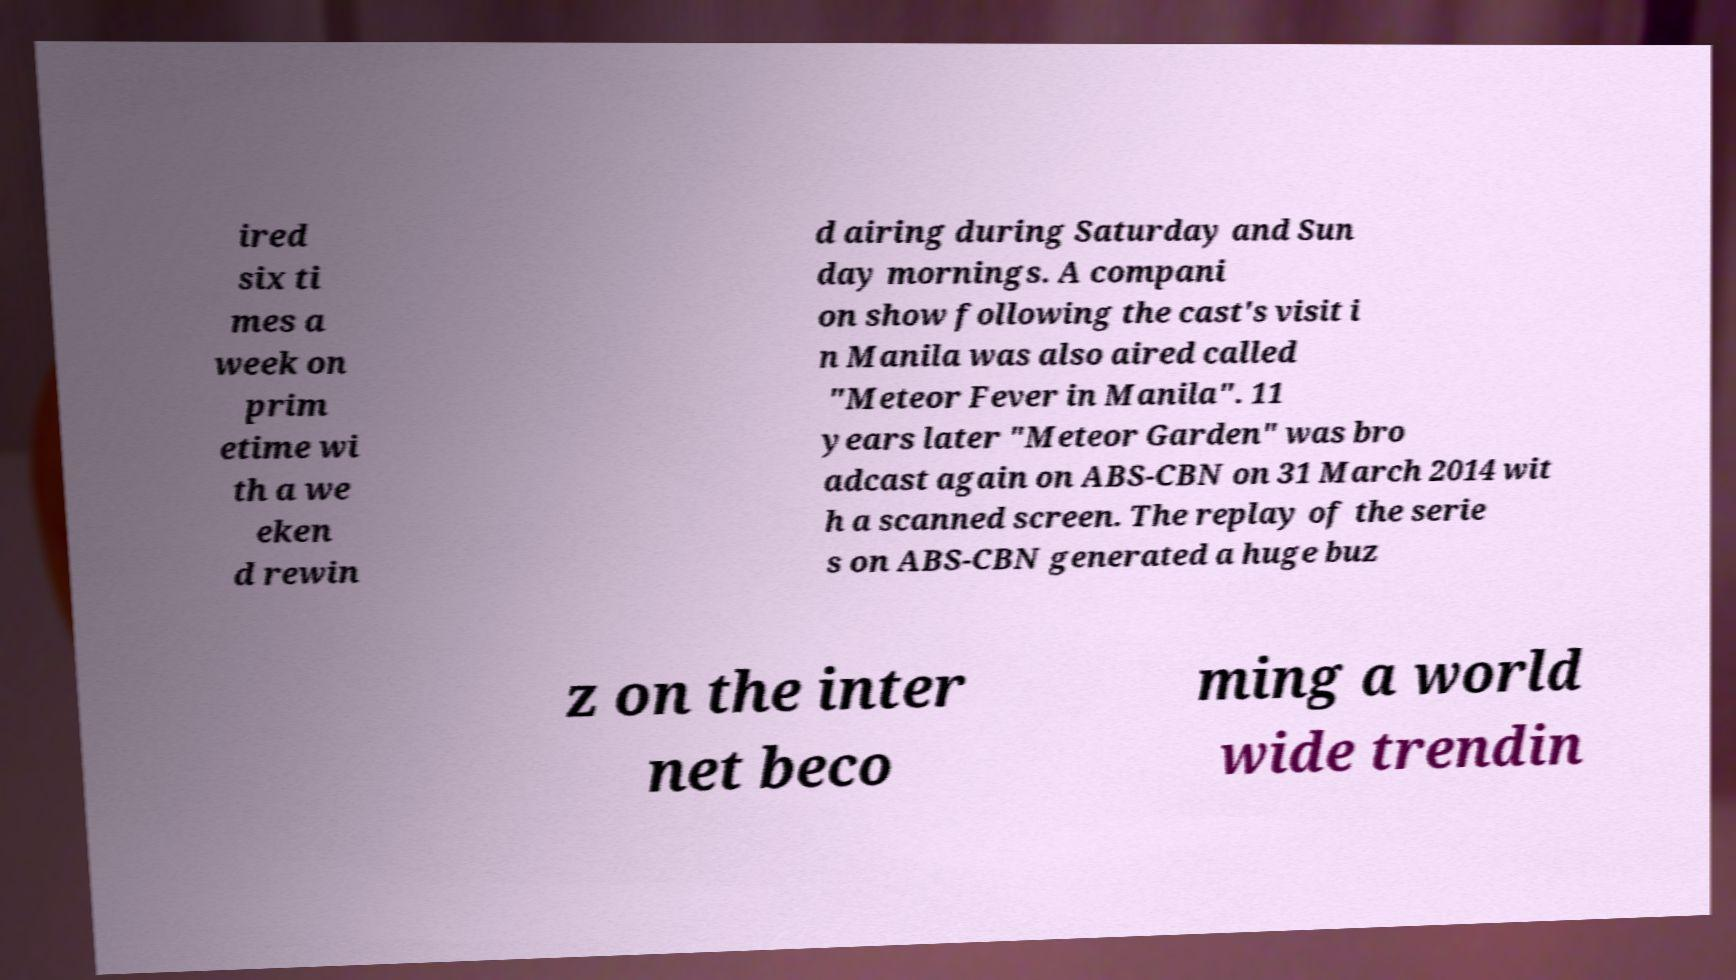For documentation purposes, I need the text within this image transcribed. Could you provide that? ired six ti mes a week on prim etime wi th a we eken d rewin d airing during Saturday and Sun day mornings. A compani on show following the cast's visit i n Manila was also aired called "Meteor Fever in Manila". 11 years later "Meteor Garden" was bro adcast again on ABS-CBN on 31 March 2014 wit h a scanned screen. The replay of the serie s on ABS-CBN generated a huge buz z on the inter net beco ming a world wide trendin 